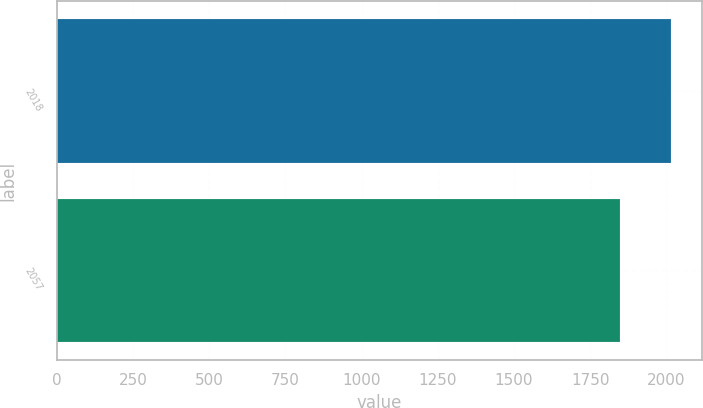<chart> <loc_0><loc_0><loc_500><loc_500><bar_chart><fcel>2018<fcel>2057<nl><fcel>2017<fcel>1849<nl></chart> 